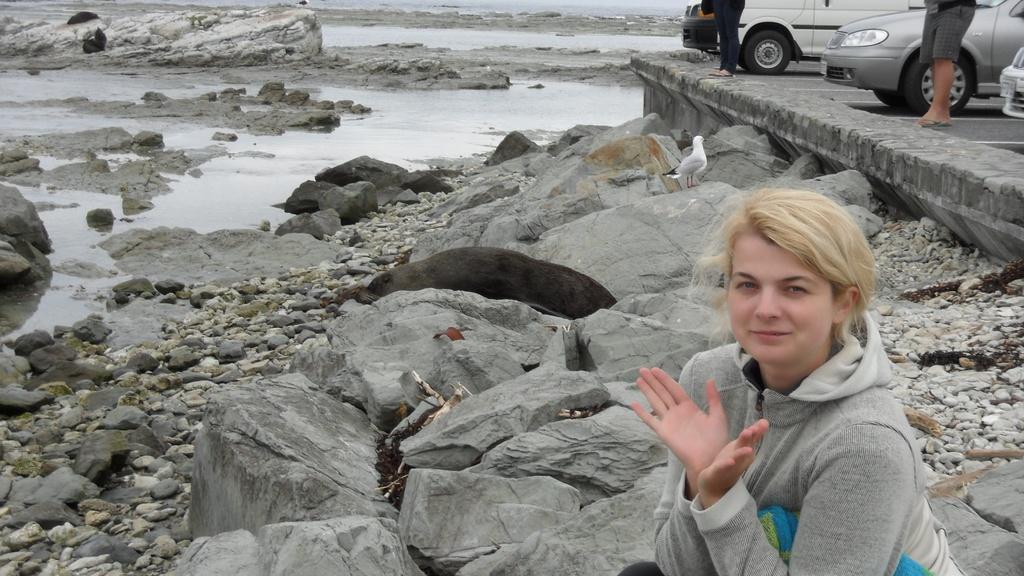Please provide a concise description of this image. In this picture I can observe a woman wearing grey color hoodie on the right side. This woman is smiling. There is an animal in the middle of this picture. On the right side there are some cars parked on the land and I can observe two members standing beside the cars. There are some rocks and stones. In the background I can observe some water. 